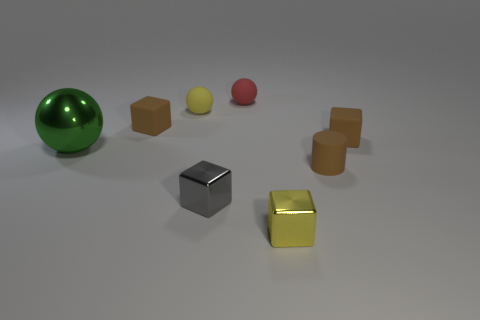Is there anything else of the same color as the big metallic sphere?
Provide a short and direct response. No. The large metal thing that is the same shape as the small red rubber object is what color?
Offer a very short reply. Green. Is the number of tiny brown matte objects that are in front of the big object greater than the number of yellow balls?
Give a very brief answer. No. What color is the small rubber object that is in front of the green metal thing?
Give a very brief answer. Brown. Do the gray object and the green shiny object have the same size?
Offer a terse response. No. The gray metal object is what size?
Provide a succinct answer. Small. Is the number of metallic blocks greater than the number of tiny brown rubber cylinders?
Make the answer very short. Yes. There is a tiny matte thing in front of the metal thing behind the small brown object in front of the big metal sphere; what color is it?
Your answer should be compact. Brown. There is a yellow object that is behind the large ball; is it the same shape as the small red object?
Provide a short and direct response. Yes. What color is the matte cylinder that is the same size as the gray thing?
Your answer should be very brief. Brown. 